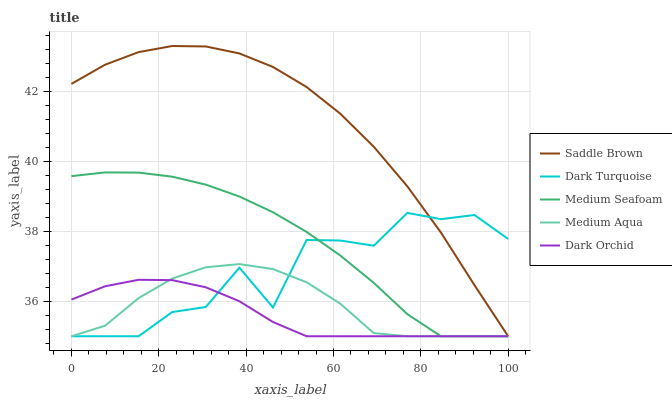Does Medium Aqua have the minimum area under the curve?
Answer yes or no. No. Does Medium Aqua have the maximum area under the curve?
Answer yes or no. No. Is Medium Aqua the smoothest?
Answer yes or no. No. Is Medium Aqua the roughest?
Answer yes or no. No. Does Medium Aqua have the highest value?
Answer yes or no. No. 